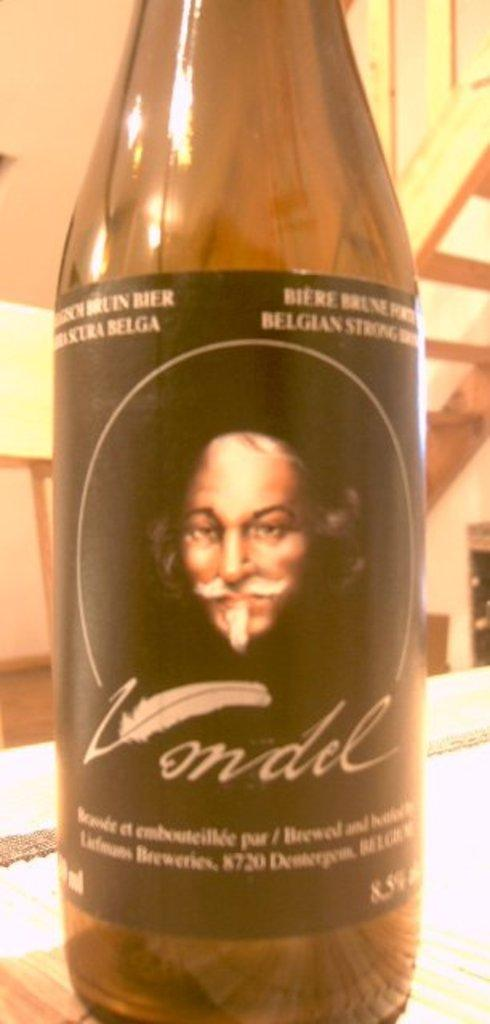<image>
Summarize the visual content of the image. The letter V on the label of an empty bottle of Vondel is made to look like an old fashioned feather pen. 